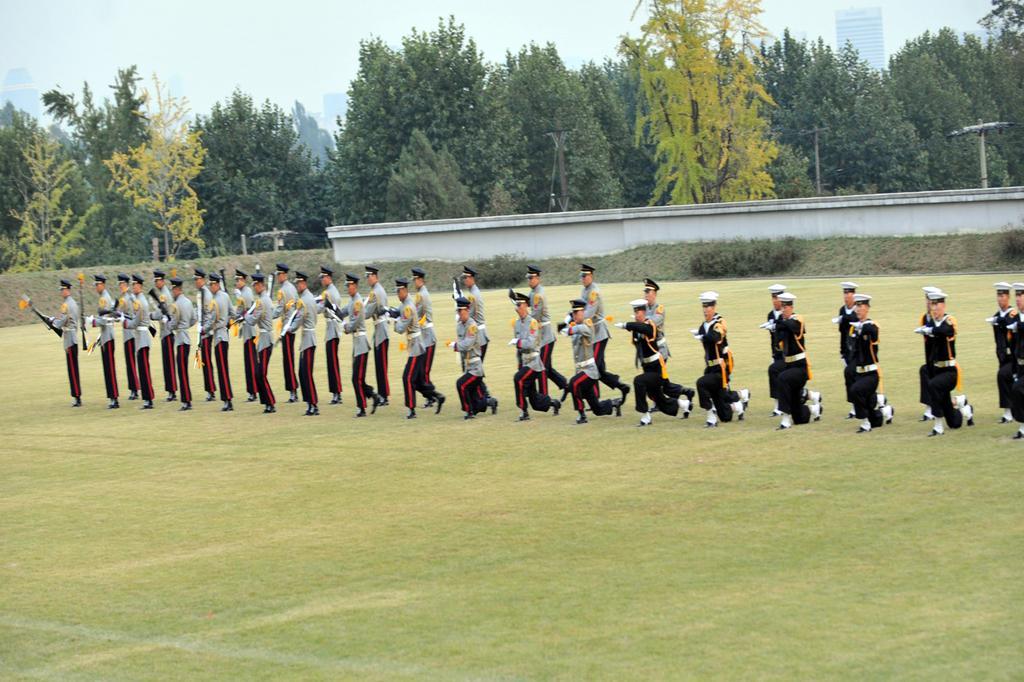Please provide a concise description of this image. In this picture we can see some people are standing, at the bottom there is grass, some of these people are holding guns, in the background we can see a wall, trees and a building, there is the sky at the top of the picture. 